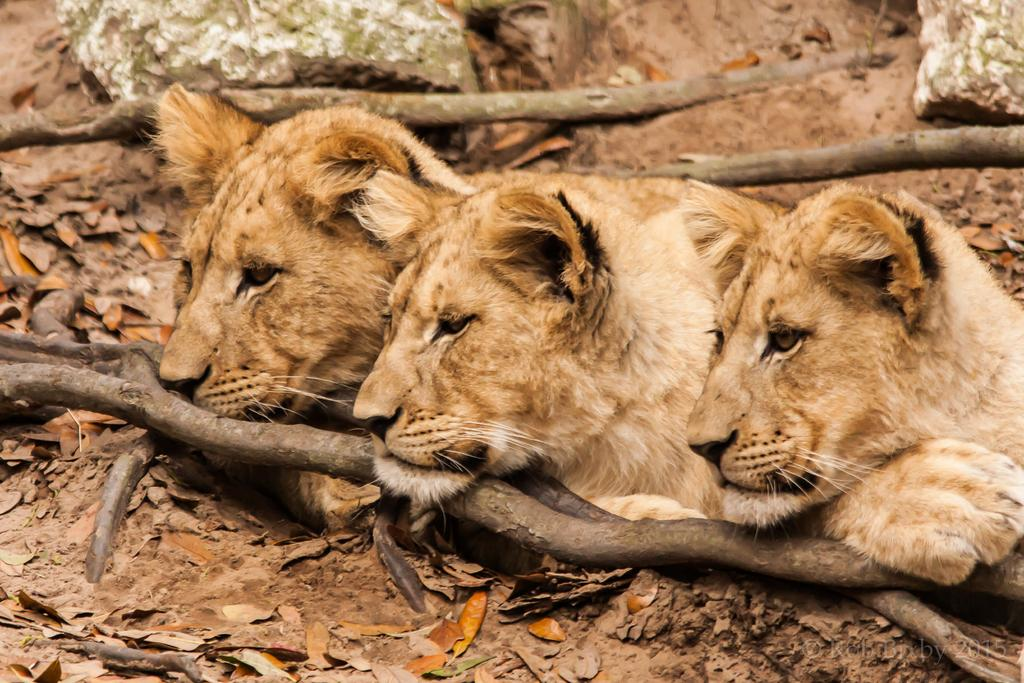How many cubs are present in the image? There are three cubs in the image. Where are the cubs located? The cubs are on the ground. What type of surface can be seen in the image? There are stones visible in the image. What type of bat is flying in the image? There is no bat present in the image; it features three cubs on the ground. What is the result of adding the number of cubs and the number of stones in the image? It is not possible to determine the number of stones from the provided facts, so we cannot perform the addition. 